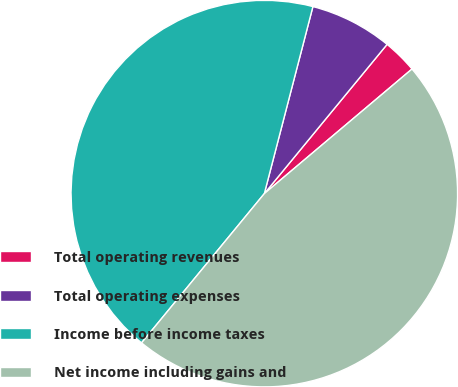<chart> <loc_0><loc_0><loc_500><loc_500><pie_chart><fcel>Total operating revenues<fcel>Total operating expenses<fcel>Income before income taxes<fcel>Net income including gains and<nl><fcel>2.89%<fcel>6.91%<fcel>43.09%<fcel>47.11%<nl></chart> 